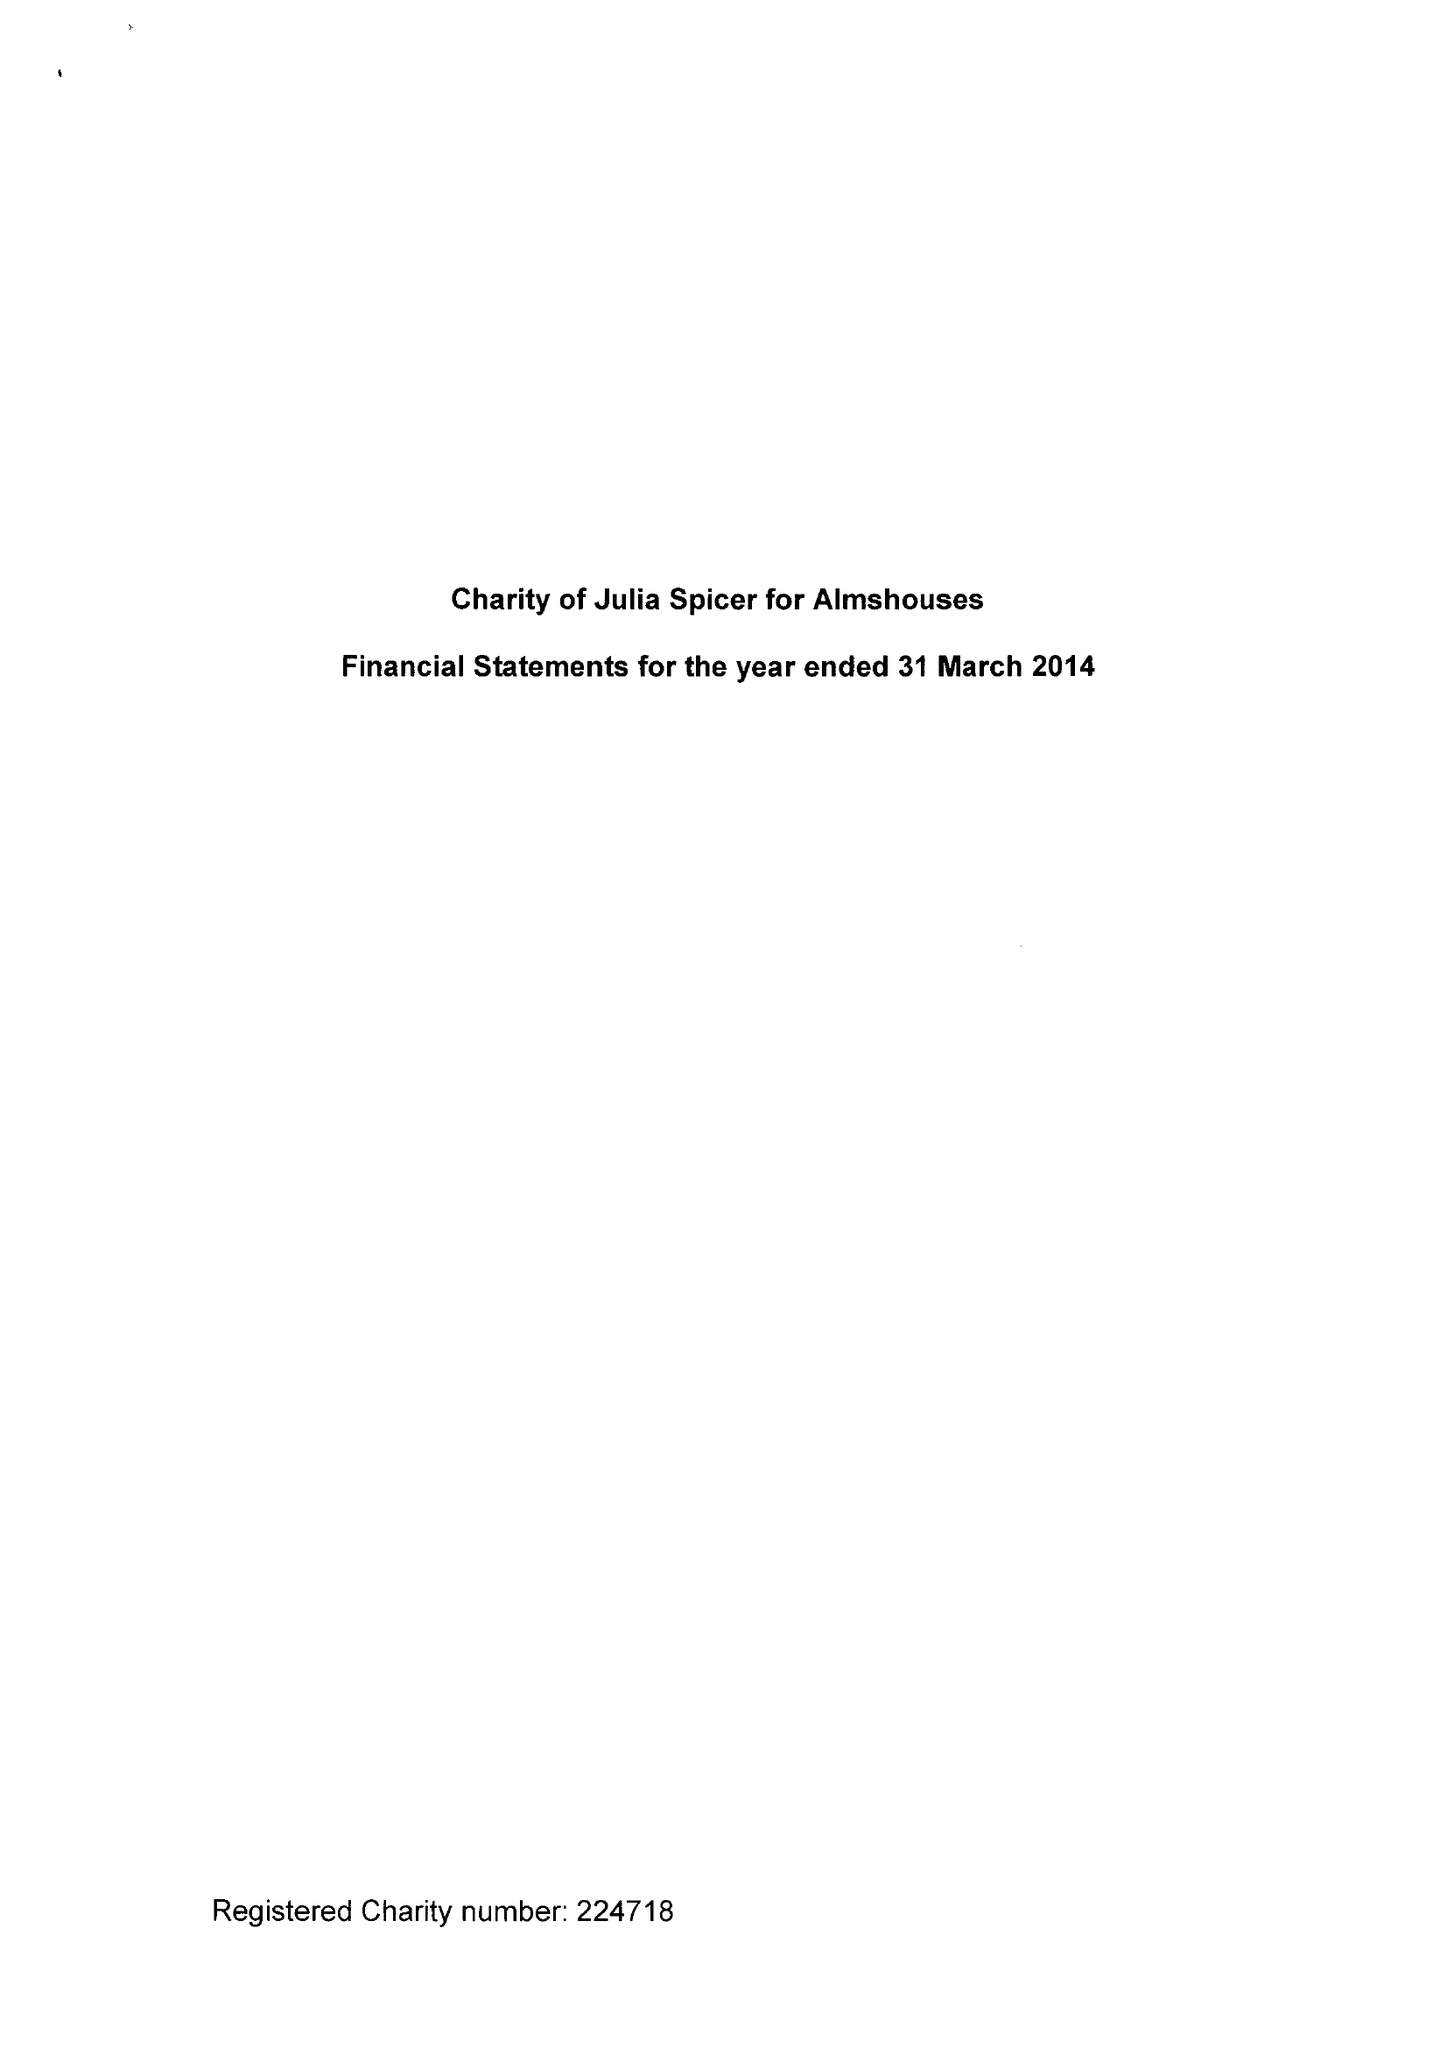What is the value for the report_date?
Answer the question using a single word or phrase. 2014-03-31 